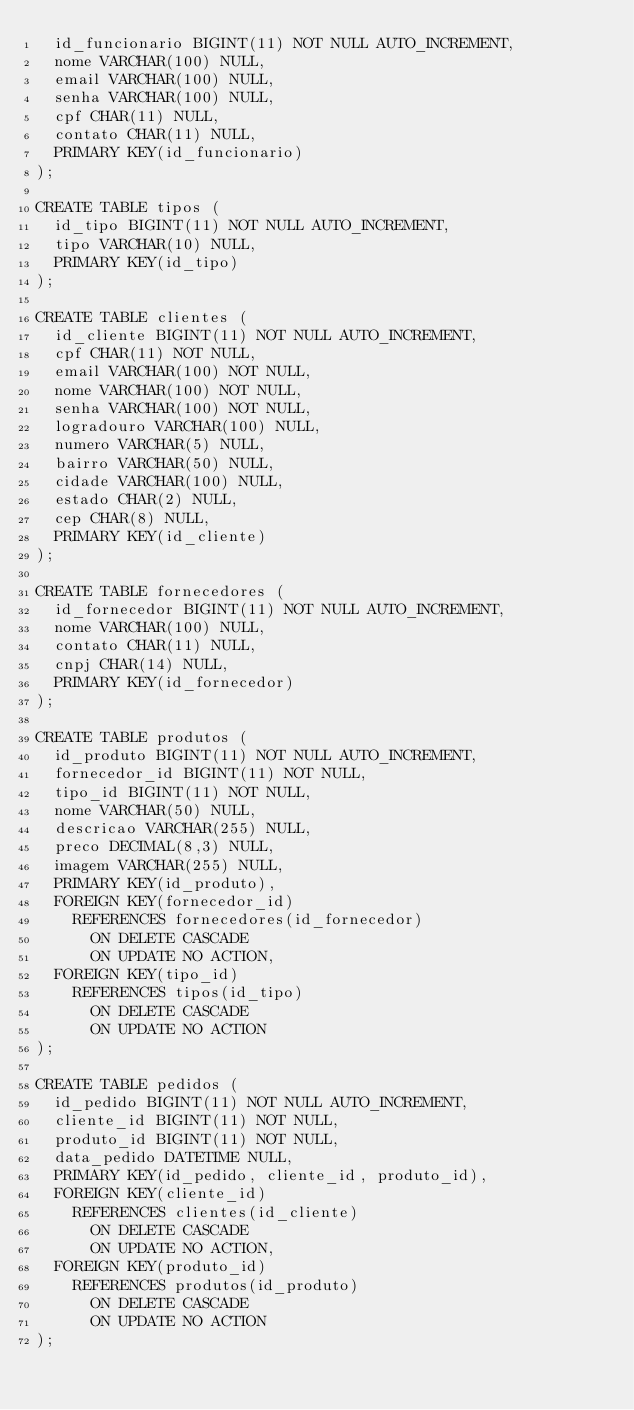<code> <loc_0><loc_0><loc_500><loc_500><_SQL_>  id_funcionario BIGINT(11) NOT NULL AUTO_INCREMENT,
  nome VARCHAR(100) NULL,
  email VARCHAR(100) NULL,
  senha VARCHAR(100) NULL,
  cpf CHAR(11) NULL,
  contato CHAR(11) NULL,
  PRIMARY KEY(id_funcionario)
);

CREATE TABLE tipos (
  id_tipo BIGINT(11) NOT NULL AUTO_INCREMENT,
  tipo VARCHAR(10) NULL,
  PRIMARY KEY(id_tipo)
);

CREATE TABLE clientes (
  id_cliente BIGINT(11) NOT NULL AUTO_INCREMENT,
  cpf CHAR(11) NOT NULL,
  email VARCHAR(100) NOT NULL,
  nome VARCHAR(100) NOT NULL,
  senha VARCHAR(100) NOT NULL,
  logradouro VARCHAR(100) NULL,
  numero VARCHAR(5) NULL,
  bairro VARCHAR(50) NULL,
  cidade VARCHAR(100) NULL,
  estado CHAR(2) NULL,
  cep CHAR(8) NULL,
  PRIMARY KEY(id_cliente)
);

CREATE TABLE fornecedores (
  id_fornecedor BIGINT(11) NOT NULL AUTO_INCREMENT,
  nome VARCHAR(100) NULL,
  contato CHAR(11) NULL,
  cnpj CHAR(14) NULL,
  PRIMARY KEY(id_fornecedor)
);

CREATE TABLE produtos (
  id_produto BIGINT(11) NOT NULL AUTO_INCREMENT,
  fornecedor_id BIGINT(11) NOT NULL,
  tipo_id BIGINT(11) NOT NULL,
  nome VARCHAR(50) NULL,
  descricao VARCHAR(255) NULL,
  preco DECIMAL(8,3) NULL,
  imagem VARCHAR(255) NULL,
  PRIMARY KEY(id_produto),
  FOREIGN KEY(fornecedor_id)
    REFERENCES fornecedores(id_fornecedor)
      ON DELETE CASCADE
      ON UPDATE NO ACTION,
  FOREIGN KEY(tipo_id)
    REFERENCES tipos(id_tipo)
      ON DELETE CASCADE
      ON UPDATE NO ACTION
);

CREATE TABLE pedidos (
  id_pedido BIGINT(11) NOT NULL AUTO_INCREMENT,
  cliente_id BIGINT(11) NOT NULL,
  produto_id BIGINT(11) NOT NULL,
  data_pedido DATETIME NULL,
  PRIMARY KEY(id_pedido, cliente_id, produto_id),
  FOREIGN KEY(cliente_id)
    REFERENCES clientes(id_cliente)
      ON DELETE CASCADE
      ON UPDATE NO ACTION,
  FOREIGN KEY(produto_id)
    REFERENCES produtos(id_produto)
      ON DELETE CASCADE
      ON UPDATE NO ACTION
);
</code> 